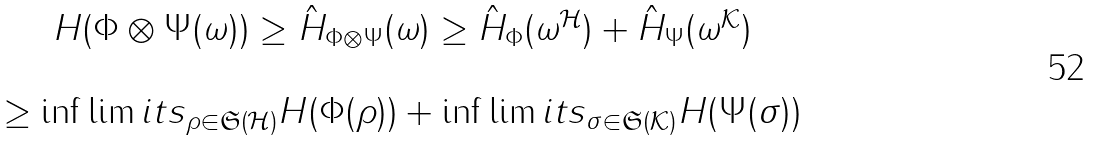Convert formula to latex. <formula><loc_0><loc_0><loc_500><loc_500>\begin{array} { c } H ( \Phi \otimes \Psi ( \omega ) ) \geq \hat { H } _ { \Phi \otimes \Psi } ( \omega ) \geq \hat { H } _ { \Phi } ( \omega ^ { \mathcal { H } } ) + \hat { H } _ { \Psi } ( \omega ^ { \mathcal { K } } ) \\ \\ \geq \inf \lim i t s _ { \rho \in \mathfrak { S } ( \mathcal { H } ) } H ( \Phi ( \rho ) ) + \inf \lim i t s _ { \sigma \in \mathfrak { S } ( \mathcal { K } ) } H ( \Psi ( \sigma ) ) \end{array}</formula> 